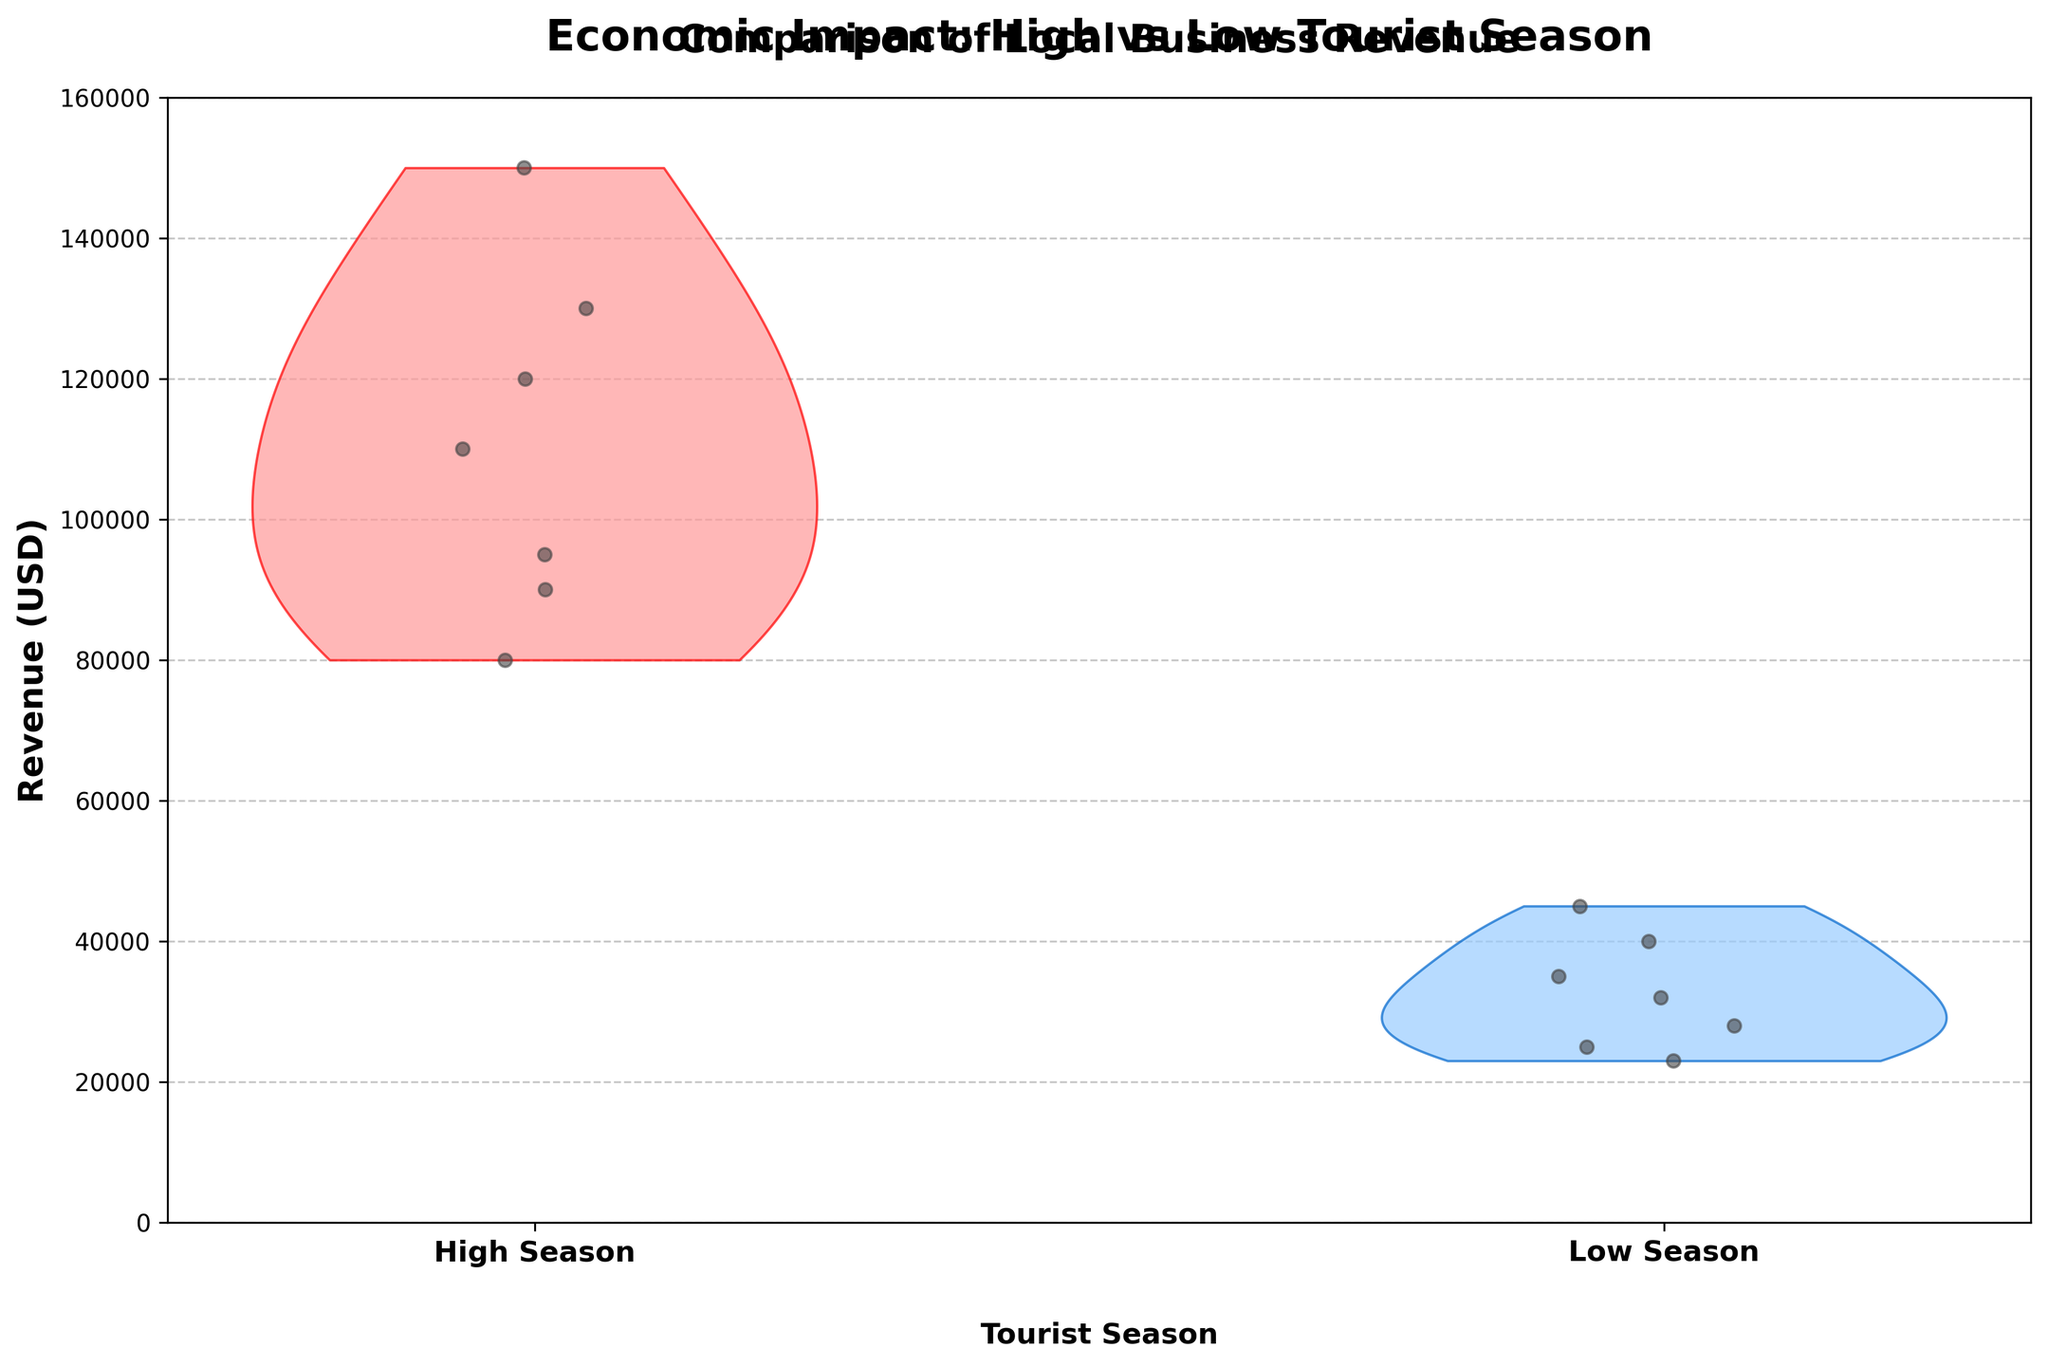What is the title of the chart? The title of the chart can be found at the top of the figure in bold text.
Answer: Economic Impact: High vs Low Tourist Season How many different local businesses are shown in the data? By counting the distinct data points represented as scatter dots in the visualization, we can infer the number of local businesses. There are 7 businesses for both high and low seasons.
Answer: 7 What is the general trend in revenue between high and low tourist seasons? The violin chart shows spread and centers of the revenue distributions. All high tourist seasons have higher revenue distributions compared to low seasons, which means more businesses earn higher revenue in the high season.
Answer: Higher in high season Which season shows a greater spread in revenue and what does this imply? By looking at the width of the violins, we can compare the spreads. High season’s violin is wider and covers a wider revenue range, which implies that there is more variability in revenue among local businesses during the high tourist season.
Answer: High season; greater variability Which season records the highest individual revenue, and what is that revenue? The highest point of the scatter plots or the extreme value seen within the high season’s violin shows the highest revenue.
Answer: High season; 150,000 USD Estimate the median revenue for local businesses in the high season. Visually, the central value or the thickest part of the high season’s violin represents the median revenue.
Answer: Approximately 110,000 USD Compare the revenue ranges between high and low seasons. By examining the vertical span of each violin, we can see high season ranges approximately from 80,000 to 150,000 USD, and low season ranges from about 23,000 to 45,000 USD.
Answer: High: 80,000-150,000 USD; Low: 23,000-45,000 USD What would be the average revenue for all businesses combined in the low season? To find the average, sum all the low season revenues: 45,000 + 25,000 + 35,000 + 28,000 + 40,000 + 23,000 + 32,000 = 228,000, then divide by the number of businesses, 7. The calculation is 228,000 / 7.
Answer: 32,571 USD Which business shows the highest drop in revenue from high to low season? By comparing the vertical positions of individual scatter points, we can track each business’ revenues between seasons. The Angkor Village Restaurant shows the highest decrease from 150,000 in high season to 45,000 in low season.
Answer: Angkor Village Restaurant 